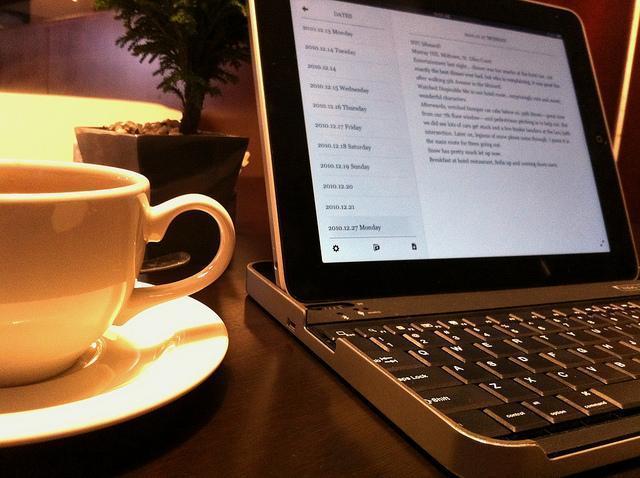How many different colors are on the mug?
Give a very brief answer. 1. How many laptops are there?
Give a very brief answer. 1. How many vases are in the photo?
Give a very brief answer. 0. 